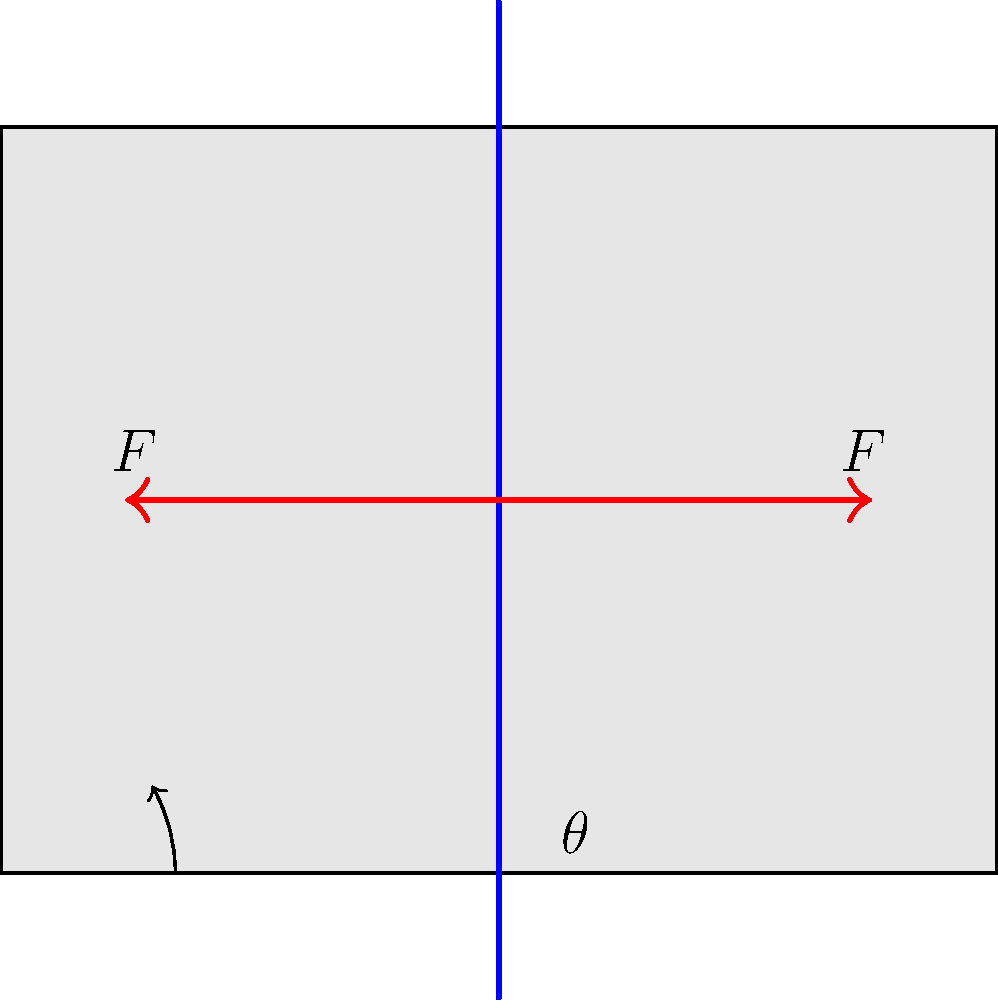As a leather goods maker, you're optimizing your cutting process. Given that the force required to cut leather is proportional to its thickness, and assuming a constant blade sharpness, what cutting angle $\theta$ would minimize the required force $F$ for a piece of leather with thickness $t$? To determine the optimal cutting angle, we need to analyze the forces involved:

1. The total force $F$ applied by the blade can be decomposed into two components:
   - Normal force $F_N$ perpendicular to the leather surface
   - Cutting force $F_C$ parallel to the leather surface

2. These forces are related to the total force $F$ and the cutting angle $\theta$ as follows:
   $F_N = F \cos \theta$
   $F_C = F \sin \theta$

3. The cutting force $F_C$ is responsible for separating the leather fibers and is proportional to the thickness $t$:
   $F_C \propto t$

4. The normal force $F_N$ contributes to friction, which increases the total required force. We want to minimize this component.

5. The total force $F$ can be expressed as:
   $F = \frac{F_C}{\sin \theta} = \frac{kt}{\sin \theta}$, where $k$ is a constant

6. To find the minimum force, we differentiate $F$ with respect to $\theta$ and set it to zero:
   $\frac{dF}{d\theta} = -kt \cot \theta \csc \theta = 0$

7. Solving this equation gives us:
   $\cot \theta = 0$
   $\theta = 45°$

Therefore, the optimal cutting angle that minimizes the required force is 45°, regardless of the leather thickness. This angle provides the best balance between the cutting force and the normal force.
Answer: 45° 